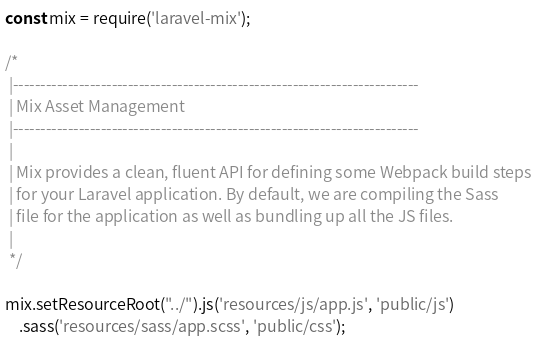Convert code to text. <code><loc_0><loc_0><loc_500><loc_500><_JavaScript_>const mix = require('laravel-mix');

/*
 |--------------------------------------------------------------------------
 | Mix Asset Management
 |--------------------------------------------------------------------------
 |
 | Mix provides a clean, fluent API for defining some Webpack build steps
 | for your Laravel application. By default, we are compiling the Sass
 | file for the application as well as bundling up all the JS files.
 |
 */

mix.setResourceRoot("../").js('resources/js/app.js', 'public/js')
    .sass('resources/sass/app.scss', 'public/css');

</code> 